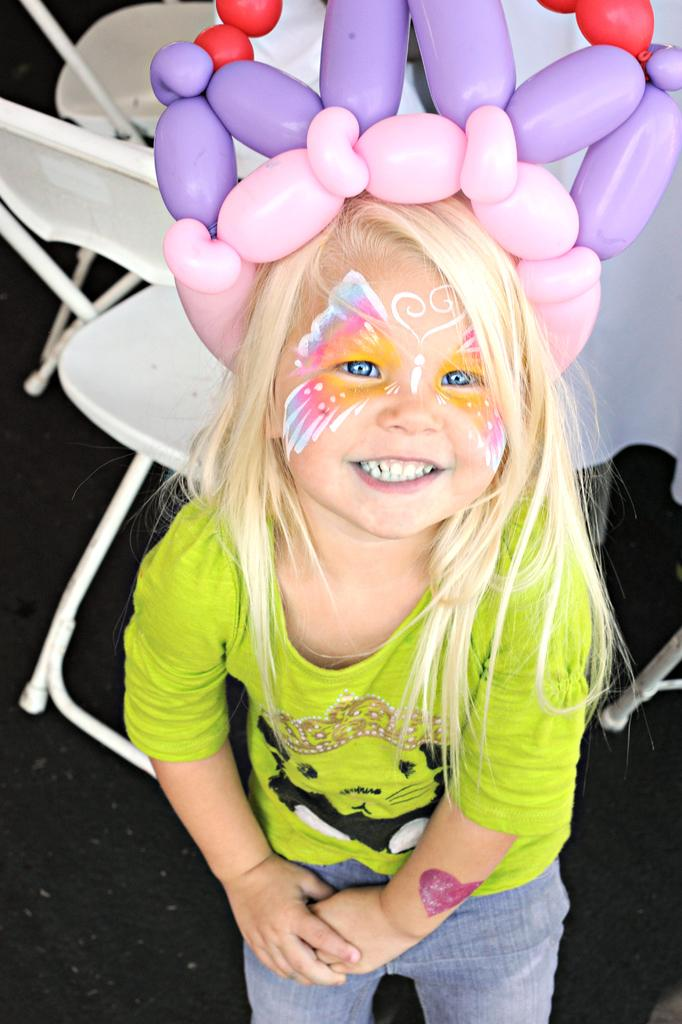Who is the main subject in the image? There is a girl in the image. What is a distinctive feature on the girl's face? The girl has a butterfly tattoo on her face. What is the girl wearing on her head? The girl is wearing a balloon crown around her head. What can be seen behind the girl in the image? There are white chairs behind the girl. What type of bubble can be seen floating near the girl in the image? There is no bubble present in the image. What kind of band is playing music in the background of the image? There is no band present in the image. 